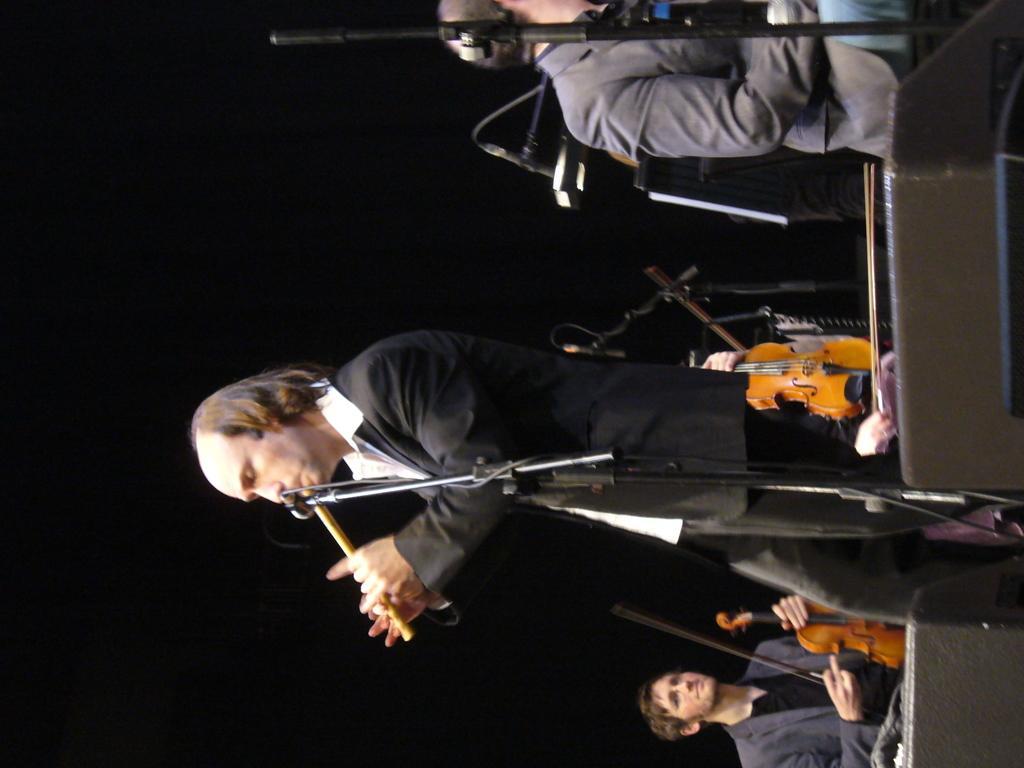Please provide a concise description of this image. In this image I see few people and I see that all of them are holding musical instruments in their hands and I see the tripods on which there are mics and I see that it is dark in the background. 